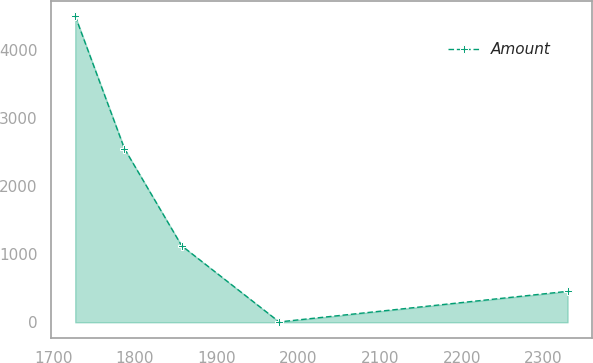Convert chart. <chart><loc_0><loc_0><loc_500><loc_500><line_chart><ecel><fcel>Amount<nl><fcel>1726.92<fcel>4499.2<nl><fcel>1787.18<fcel>2550.14<nl><fcel>1857.2<fcel>1124.77<nl><fcel>1976.53<fcel>5.75<nl><fcel>2329.51<fcel>455.1<nl></chart> 